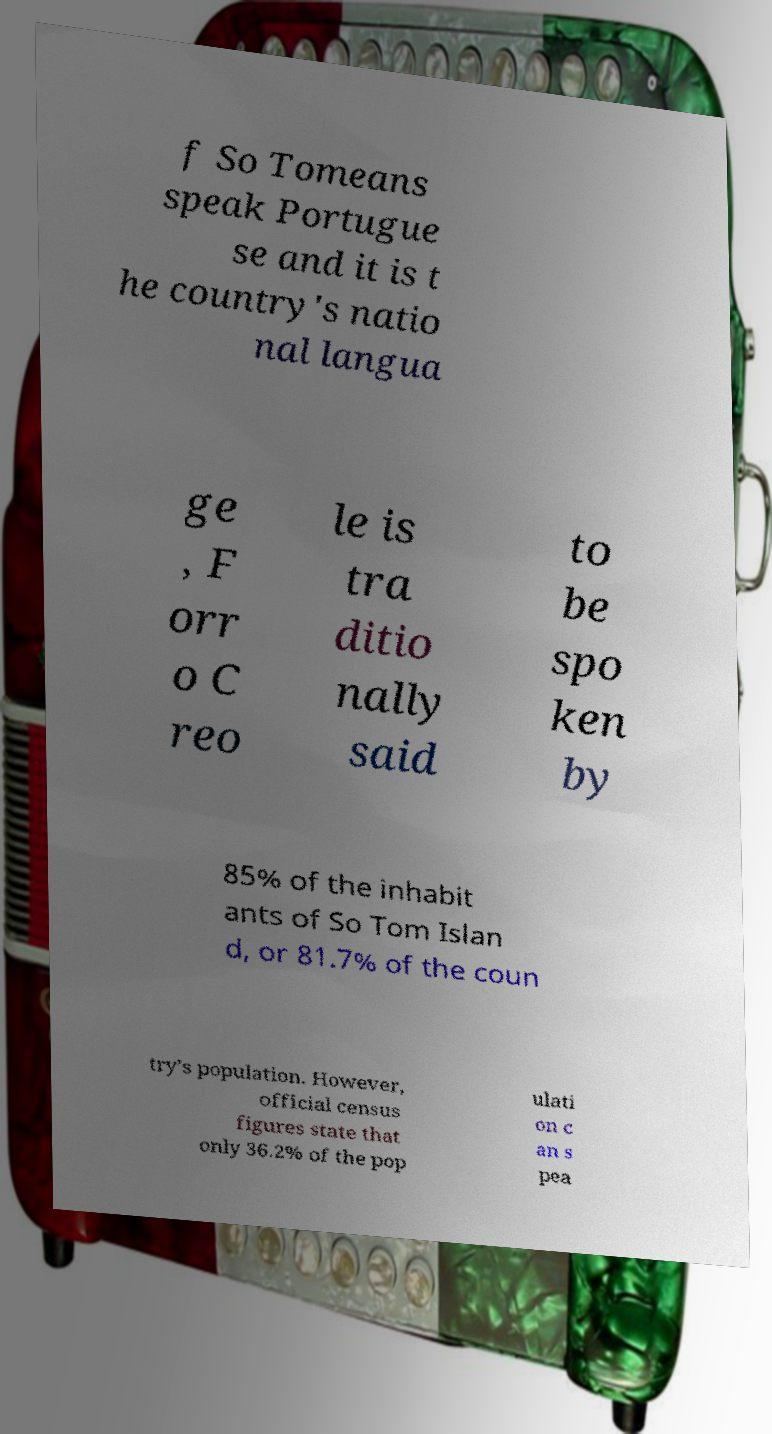I need the written content from this picture converted into text. Can you do that? f So Tomeans speak Portugue se and it is t he country's natio nal langua ge , F orr o C reo le is tra ditio nally said to be spo ken by 85% of the inhabit ants of So Tom Islan d, or 81.7% of the coun try’s population. However, official census figures state that only 36.2% of the pop ulati on c an s pea 